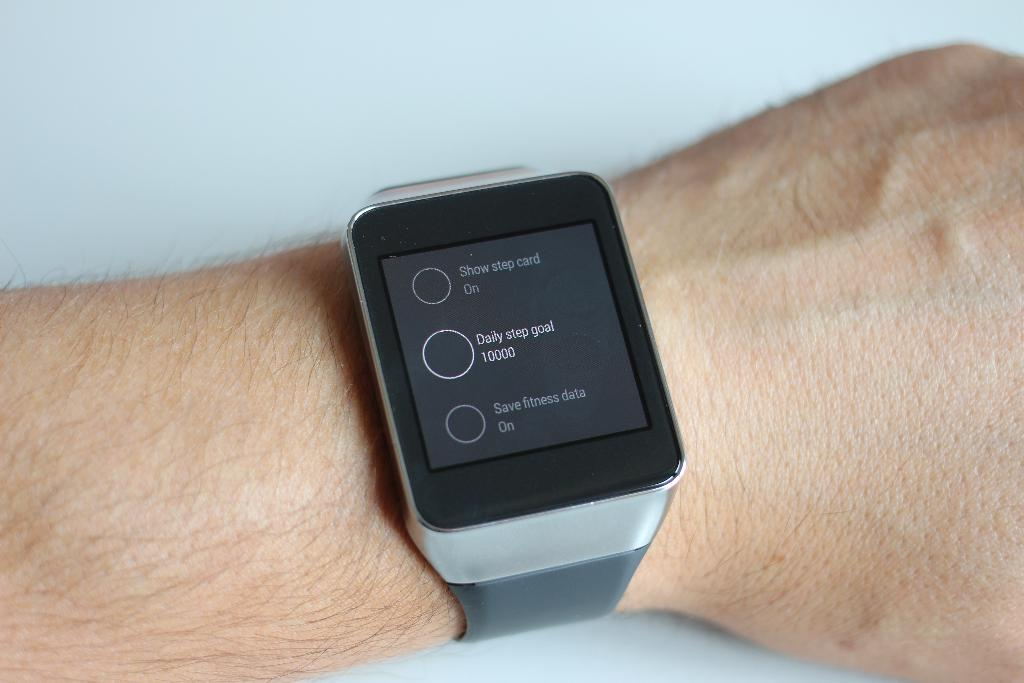<image>
Share a concise interpretation of the image provided. A smart watch with options such as "Show step card", "Daily step goal", and "Save fitness data". 